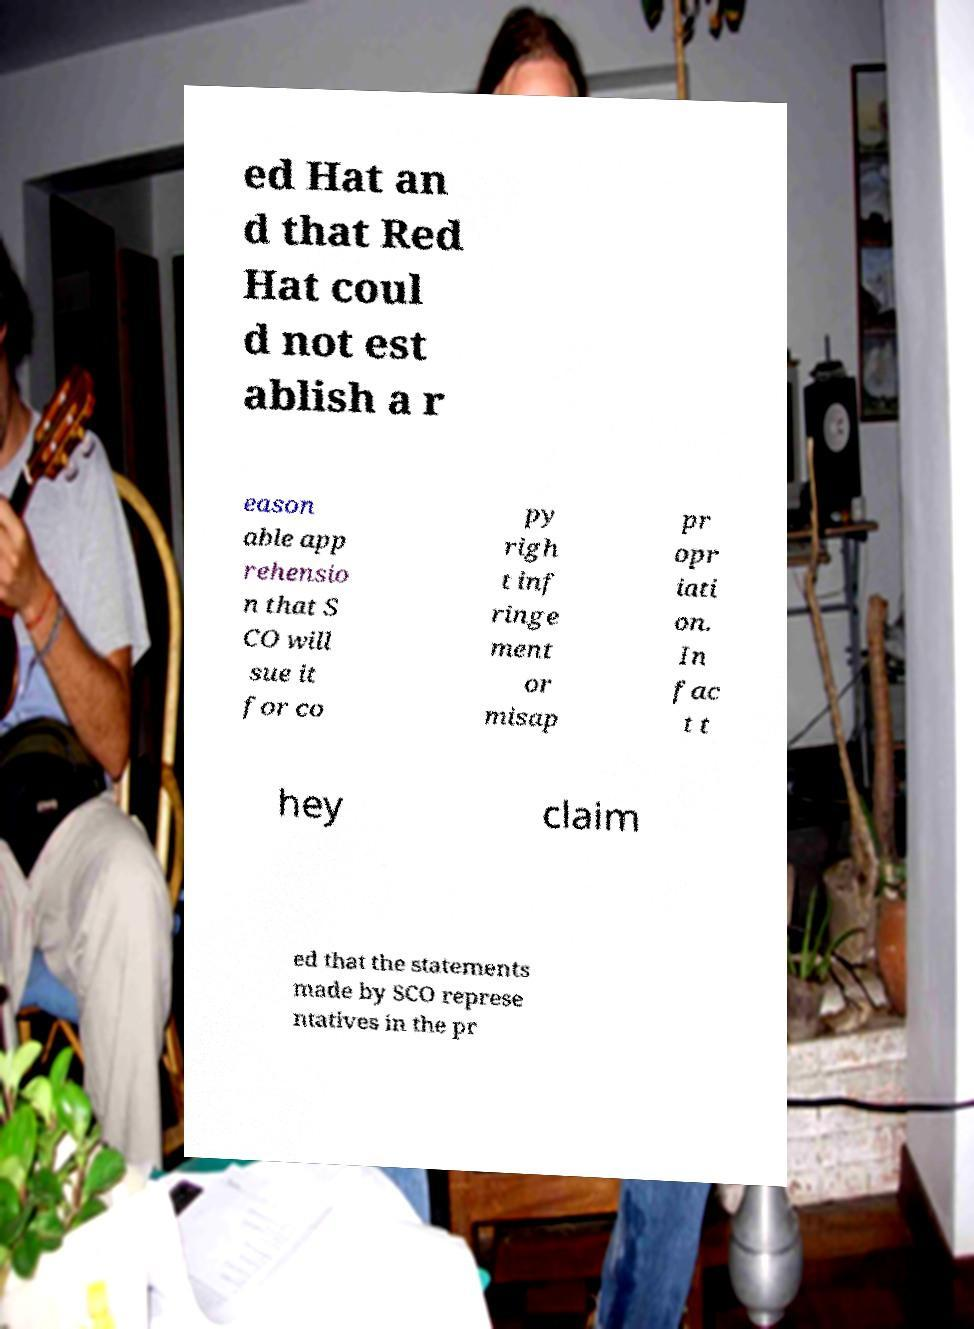What messages or text are displayed in this image? I need them in a readable, typed format. ed Hat an d that Red Hat coul d not est ablish a r eason able app rehensio n that S CO will sue it for co py righ t inf ringe ment or misap pr opr iati on. In fac t t hey claim ed that the statements made by SCO represe ntatives in the pr 